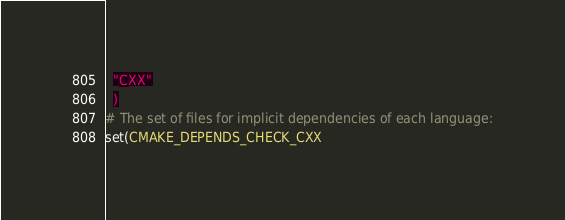<code> <loc_0><loc_0><loc_500><loc_500><_CMake_>  "CXX"
  )
# The set of files for implicit dependencies of each language:
set(CMAKE_DEPENDS_CHECK_CXX</code> 